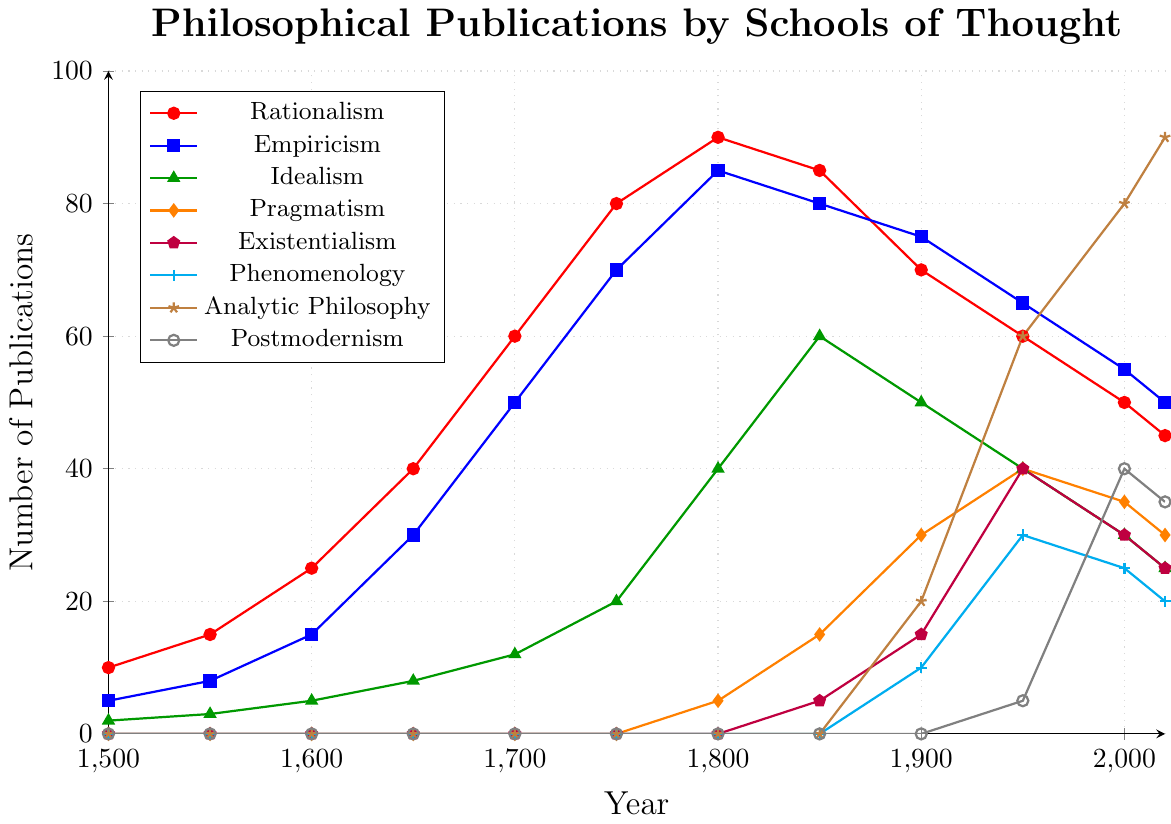Which school of thought saw the highest number of publications in 1850? First, identify the data points for each school of thought in 1850 on the chart. Rationalism had 85, Empiricism had 80, Idealism had 60, Pragmatism had 15, Existentialism had 5, Phenomenology had 0, Analytic Philosophy had 0, and Postmodernism had 0. Rationalism and Empiricism are the highest with Rationalism slightly leading.
Answer: Rationalism When did Idealism reach its peak number of publications? Observe the curve representing Idealism (green with triangle markers) and notice its highest point. The peak is at 1800 with 40 publications.
Answer: 1800 By how much do Pragmatism publications in 2020 exceed Pragmatism publications in 1800? Check the number of Pragmatism publications in 2020 (30) and 1800 (5). Subtract the 1800 value from the 2020 value: 30 - 5 = 25.
Answer: 25 Which school had more publications in 1950: Existentialism or Phenomenology? Look at the publication numbers for both Existentialism (purple with pentagon markers) and Phenomenology (cyan with plus markers) in 1950. Existentialism has 40 and Phenomenology has 30.
Answer: Existentialism How do the publication trends of Rationalism and Empiricism compare between 1600 and 1850? Examine the Rationalism (red) and Empiricism (blue) trends from 1600 to 1850. Rationalism starts higher but grows less steeply in the mid-period and then slightly declines before 1850, while Empiricism shows a consistent upward trend before slightly dropping before 1850.
Answer: Rationalism peaks early and declines; Empiricism consistently rises What is the average number of Empiricism publications from 1500 to 2020? Add publication numbers for Empiricism across all years: (5 + 8 + 15 + 30 + 50 + 70 + 85 + 80 + 75 + 65 + 55 + 50) which totals 588. Divide by the number of years (12): 588 / 12 = 49.
Answer: 49 Which school of thought appeared the latest in the publication record? Determine the first non-zero publication value for each school. Analytic Philosophy (brown with star markers) first appears in 1900.
Answer: Analytic Philosophy How many more publications does Analytic Philosophy have in 2020 compared to Phenomenology in 1900? Identify Analytic Philosophy publications in 2020 (90) and Phenomenology in 1900 (10). Subtract 10 from 90: 90 - 10 = 80.
Answer: 80 When did Postmodernism see a sharp increase in its publication record? Look at the curve for Postmodernism (gray with circle markers) and note the steep rise. The increase is noticeable between 1950 (5) and 2000 (40).
Answer: 1950-2000 